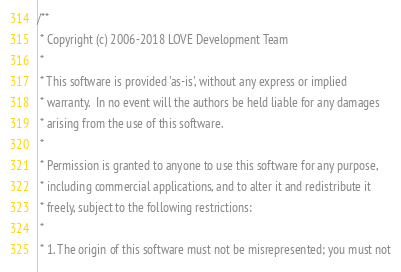Convert code to text. <code><loc_0><loc_0><loc_500><loc_500><_C++_>/**
 * Copyright (c) 2006-2018 LOVE Development Team
 *
 * This software is provided 'as-is', without any express or implied
 * warranty.  In no event will the authors be held liable for any damages
 * arising from the use of this software.
 *
 * Permission is granted to anyone to use this software for any purpose,
 * including commercial applications, and to alter it and redistribute it
 * freely, subject to the following restrictions:
 *
 * 1. The origin of this software must not be misrepresented; you must not</code> 